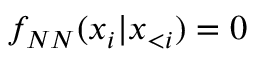<formula> <loc_0><loc_0><loc_500><loc_500>f _ { N N } ( x _ { i } | \boldsymbol x _ { < i } ) = 0</formula> 